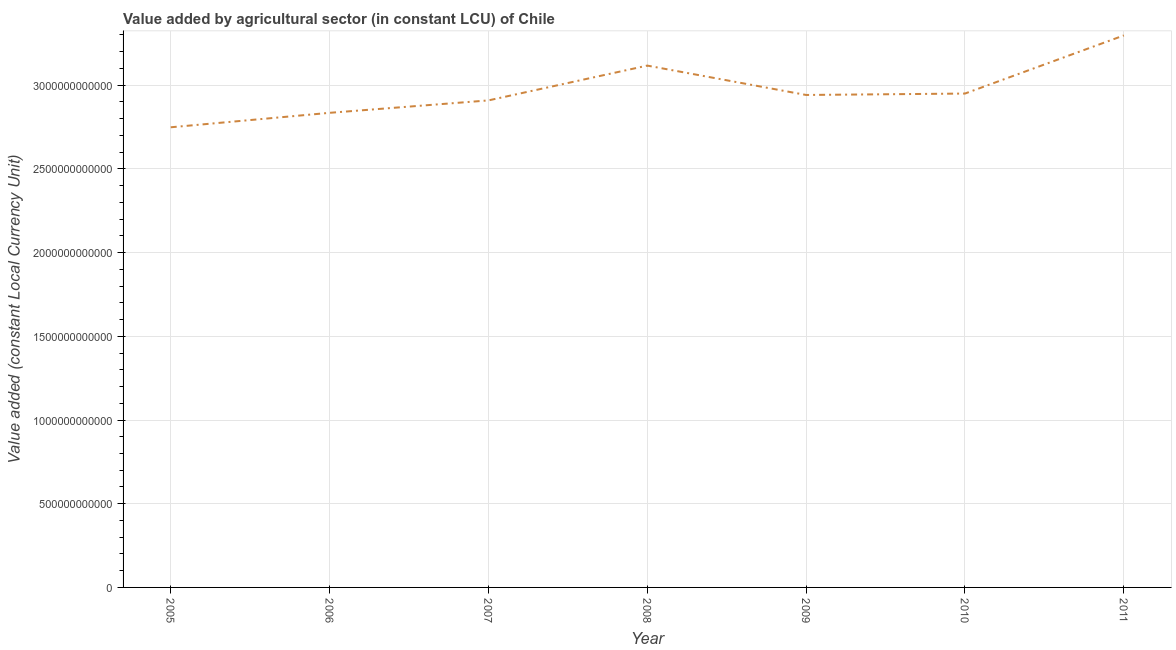What is the value added by agriculture sector in 2005?
Provide a succinct answer. 2.75e+12. Across all years, what is the maximum value added by agriculture sector?
Offer a very short reply. 3.30e+12. Across all years, what is the minimum value added by agriculture sector?
Offer a very short reply. 2.75e+12. What is the sum of the value added by agriculture sector?
Keep it short and to the point. 2.08e+13. What is the difference between the value added by agriculture sector in 2008 and 2011?
Offer a very short reply. -1.80e+11. What is the average value added by agriculture sector per year?
Your answer should be very brief. 2.97e+12. What is the median value added by agriculture sector?
Your answer should be very brief. 2.94e+12. In how many years, is the value added by agriculture sector greater than 700000000000 LCU?
Your answer should be very brief. 7. Do a majority of the years between 2011 and 2007 (inclusive) have value added by agriculture sector greater than 1300000000000 LCU?
Offer a very short reply. Yes. What is the ratio of the value added by agriculture sector in 2005 to that in 2008?
Give a very brief answer. 0.88. Is the value added by agriculture sector in 2010 less than that in 2011?
Your answer should be very brief. Yes. What is the difference between the highest and the second highest value added by agriculture sector?
Your answer should be compact. 1.80e+11. Is the sum of the value added by agriculture sector in 2008 and 2011 greater than the maximum value added by agriculture sector across all years?
Ensure brevity in your answer.  Yes. What is the difference between the highest and the lowest value added by agriculture sector?
Give a very brief answer. 5.49e+11. Does the value added by agriculture sector monotonically increase over the years?
Offer a very short reply. No. What is the difference between two consecutive major ticks on the Y-axis?
Give a very brief answer. 5.00e+11. Are the values on the major ticks of Y-axis written in scientific E-notation?
Offer a very short reply. No. What is the title of the graph?
Your answer should be very brief. Value added by agricultural sector (in constant LCU) of Chile. What is the label or title of the Y-axis?
Offer a terse response. Value added (constant Local Currency Unit). What is the Value added (constant Local Currency Unit) in 2005?
Keep it short and to the point. 2.75e+12. What is the Value added (constant Local Currency Unit) in 2006?
Keep it short and to the point. 2.83e+12. What is the Value added (constant Local Currency Unit) in 2007?
Provide a succinct answer. 2.91e+12. What is the Value added (constant Local Currency Unit) of 2008?
Offer a terse response. 3.12e+12. What is the Value added (constant Local Currency Unit) in 2009?
Ensure brevity in your answer.  2.94e+12. What is the Value added (constant Local Currency Unit) in 2010?
Your answer should be very brief. 2.95e+12. What is the Value added (constant Local Currency Unit) in 2011?
Your answer should be very brief. 3.30e+12. What is the difference between the Value added (constant Local Currency Unit) in 2005 and 2006?
Your response must be concise. -8.64e+1. What is the difference between the Value added (constant Local Currency Unit) in 2005 and 2007?
Provide a short and direct response. -1.61e+11. What is the difference between the Value added (constant Local Currency Unit) in 2005 and 2008?
Your answer should be compact. -3.69e+11. What is the difference between the Value added (constant Local Currency Unit) in 2005 and 2009?
Your response must be concise. -1.93e+11. What is the difference between the Value added (constant Local Currency Unit) in 2005 and 2010?
Keep it short and to the point. -2.01e+11. What is the difference between the Value added (constant Local Currency Unit) in 2005 and 2011?
Make the answer very short. -5.49e+11. What is the difference between the Value added (constant Local Currency Unit) in 2006 and 2007?
Provide a succinct answer. -7.42e+1. What is the difference between the Value added (constant Local Currency Unit) in 2006 and 2008?
Give a very brief answer. -2.82e+11. What is the difference between the Value added (constant Local Currency Unit) in 2006 and 2009?
Offer a terse response. -1.07e+11. What is the difference between the Value added (constant Local Currency Unit) in 2006 and 2010?
Your answer should be compact. -1.15e+11. What is the difference between the Value added (constant Local Currency Unit) in 2006 and 2011?
Give a very brief answer. -4.62e+11. What is the difference between the Value added (constant Local Currency Unit) in 2007 and 2008?
Your answer should be compact. -2.08e+11. What is the difference between the Value added (constant Local Currency Unit) in 2007 and 2009?
Provide a short and direct response. -3.25e+1. What is the difference between the Value added (constant Local Currency Unit) in 2007 and 2010?
Provide a short and direct response. -4.09e+1. What is the difference between the Value added (constant Local Currency Unit) in 2007 and 2011?
Your answer should be very brief. -3.88e+11. What is the difference between the Value added (constant Local Currency Unit) in 2008 and 2009?
Provide a succinct answer. 1.75e+11. What is the difference between the Value added (constant Local Currency Unit) in 2008 and 2010?
Give a very brief answer. 1.67e+11. What is the difference between the Value added (constant Local Currency Unit) in 2008 and 2011?
Offer a very short reply. -1.80e+11. What is the difference between the Value added (constant Local Currency Unit) in 2009 and 2010?
Your response must be concise. -8.46e+09. What is the difference between the Value added (constant Local Currency Unit) in 2009 and 2011?
Offer a terse response. -3.56e+11. What is the difference between the Value added (constant Local Currency Unit) in 2010 and 2011?
Your response must be concise. -3.47e+11. What is the ratio of the Value added (constant Local Currency Unit) in 2005 to that in 2006?
Offer a very short reply. 0.97. What is the ratio of the Value added (constant Local Currency Unit) in 2005 to that in 2007?
Give a very brief answer. 0.94. What is the ratio of the Value added (constant Local Currency Unit) in 2005 to that in 2008?
Your answer should be very brief. 0.88. What is the ratio of the Value added (constant Local Currency Unit) in 2005 to that in 2009?
Your answer should be compact. 0.93. What is the ratio of the Value added (constant Local Currency Unit) in 2005 to that in 2010?
Keep it short and to the point. 0.93. What is the ratio of the Value added (constant Local Currency Unit) in 2005 to that in 2011?
Give a very brief answer. 0.83. What is the ratio of the Value added (constant Local Currency Unit) in 2006 to that in 2007?
Keep it short and to the point. 0.97. What is the ratio of the Value added (constant Local Currency Unit) in 2006 to that in 2008?
Provide a succinct answer. 0.91. What is the ratio of the Value added (constant Local Currency Unit) in 2006 to that in 2011?
Your answer should be very brief. 0.86. What is the ratio of the Value added (constant Local Currency Unit) in 2007 to that in 2008?
Your answer should be compact. 0.93. What is the ratio of the Value added (constant Local Currency Unit) in 2007 to that in 2010?
Offer a very short reply. 0.99. What is the ratio of the Value added (constant Local Currency Unit) in 2007 to that in 2011?
Your answer should be very brief. 0.88. What is the ratio of the Value added (constant Local Currency Unit) in 2008 to that in 2009?
Offer a terse response. 1.06. What is the ratio of the Value added (constant Local Currency Unit) in 2008 to that in 2010?
Ensure brevity in your answer.  1.06. What is the ratio of the Value added (constant Local Currency Unit) in 2008 to that in 2011?
Your answer should be compact. 0.94. What is the ratio of the Value added (constant Local Currency Unit) in 2009 to that in 2011?
Your response must be concise. 0.89. What is the ratio of the Value added (constant Local Currency Unit) in 2010 to that in 2011?
Your answer should be very brief. 0.9. 